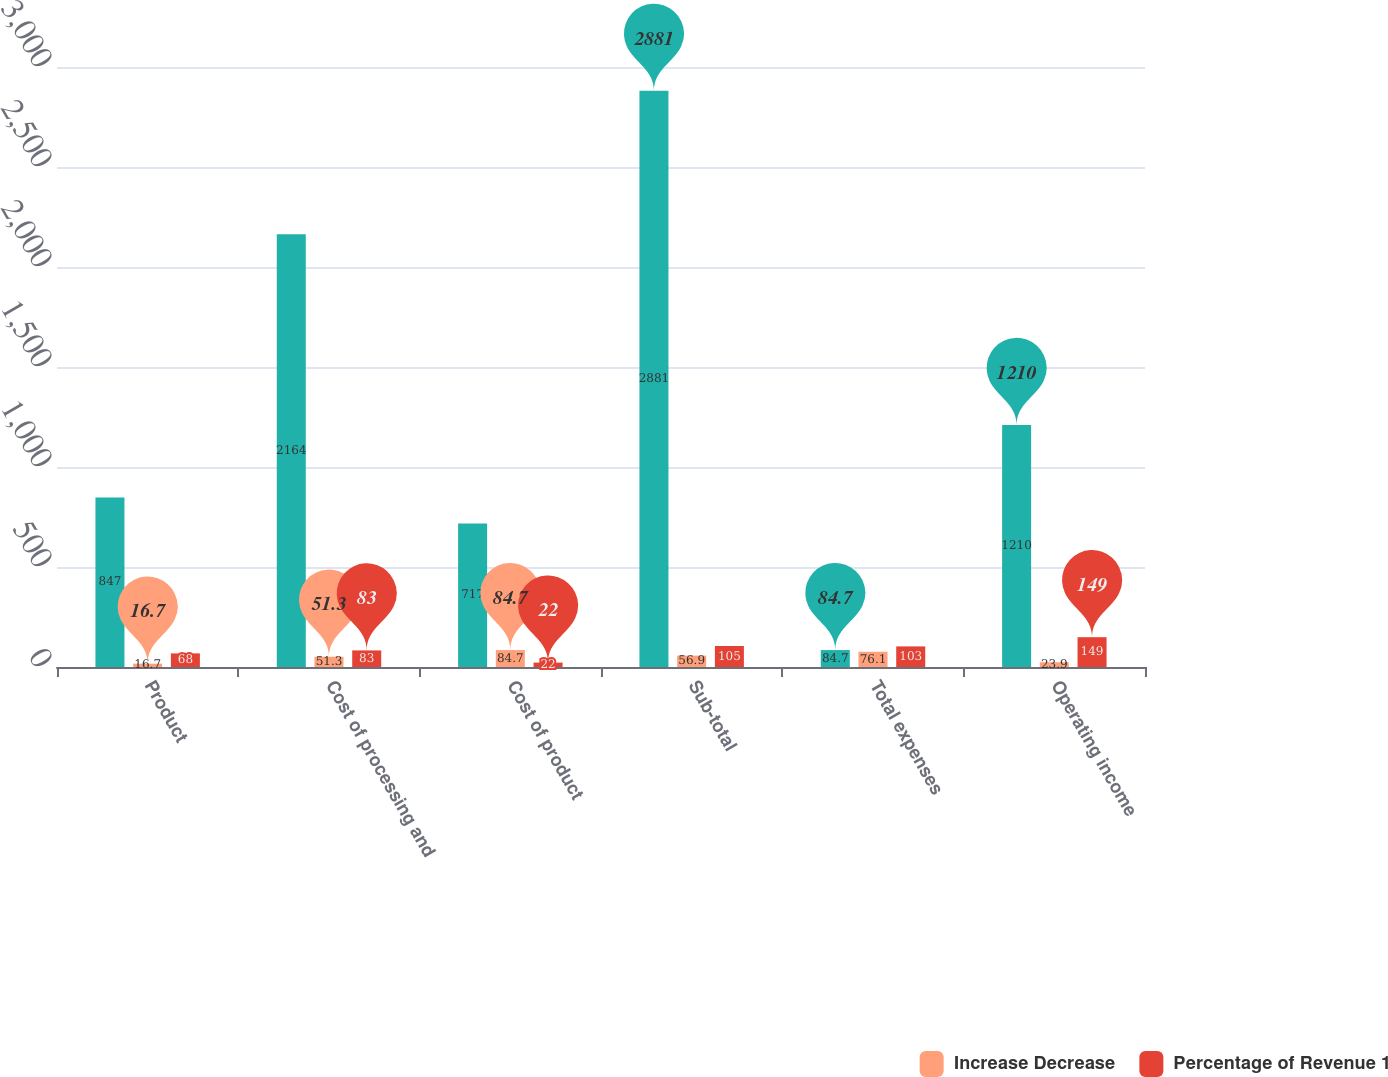Convert chart. <chart><loc_0><loc_0><loc_500><loc_500><stacked_bar_chart><ecel><fcel>Product<fcel>Cost of processing and<fcel>Cost of product<fcel>Sub-total<fcel>Total expenses<fcel>Operating income<nl><fcel>nan<fcel>847<fcel>2164<fcel>717<fcel>2881<fcel>84.7<fcel>1210<nl><fcel>Increase Decrease<fcel>16.7<fcel>51.3<fcel>84.7<fcel>56.9<fcel>76.1<fcel>23.9<nl><fcel>Percentage of Revenue 1<fcel>68<fcel>83<fcel>22<fcel>105<fcel>103<fcel>149<nl></chart> 